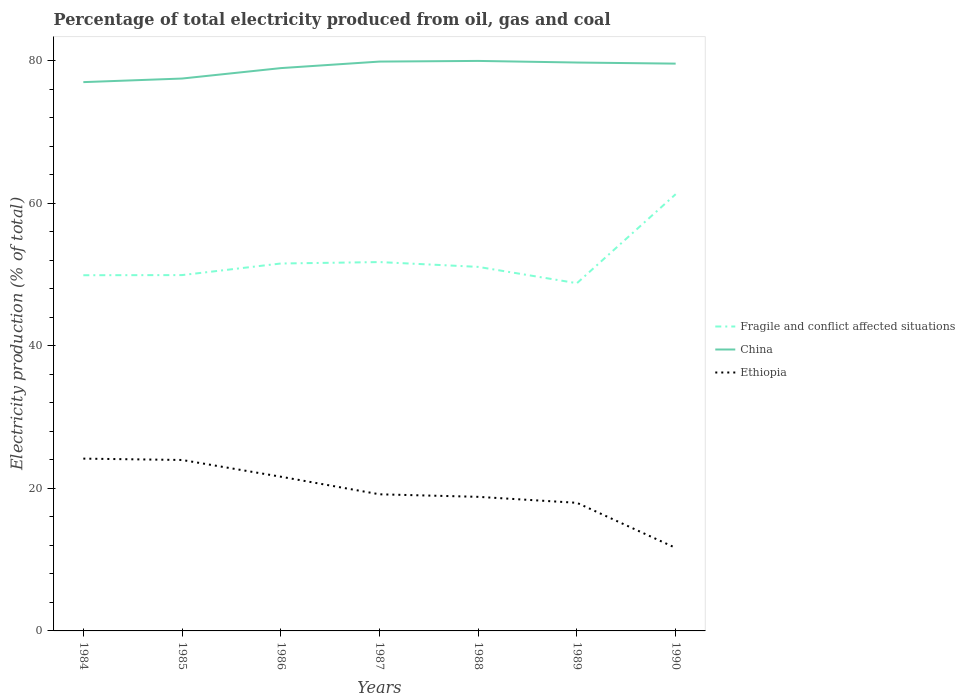Is the number of lines equal to the number of legend labels?
Your response must be concise. Yes. Across all years, what is the maximum electricity production in in Fragile and conflict affected situations?
Your answer should be compact. 48.79. What is the total electricity production in in China in the graph?
Give a very brief answer. 0.22. What is the difference between the highest and the second highest electricity production in in China?
Your answer should be compact. 2.97. What is the difference between the highest and the lowest electricity production in in Ethiopia?
Give a very brief answer. 3. Is the electricity production in in Fragile and conflict affected situations strictly greater than the electricity production in in Ethiopia over the years?
Your answer should be compact. No. How many lines are there?
Keep it short and to the point. 3. How many years are there in the graph?
Ensure brevity in your answer.  7. Does the graph contain any zero values?
Ensure brevity in your answer.  No. How many legend labels are there?
Keep it short and to the point. 3. How are the legend labels stacked?
Provide a short and direct response. Vertical. What is the title of the graph?
Offer a very short reply. Percentage of total electricity produced from oil, gas and coal. What is the label or title of the X-axis?
Offer a terse response. Years. What is the label or title of the Y-axis?
Your answer should be very brief. Electricity production (% of total). What is the Electricity production (% of total) in Fragile and conflict affected situations in 1984?
Keep it short and to the point. 49.91. What is the Electricity production (% of total) in China in 1984?
Provide a succinct answer. 77.01. What is the Electricity production (% of total) of Ethiopia in 1984?
Your answer should be compact. 24.18. What is the Electricity production (% of total) of Fragile and conflict affected situations in 1985?
Your answer should be compact. 49.93. What is the Electricity production (% of total) of China in 1985?
Provide a short and direct response. 77.51. What is the Electricity production (% of total) in Ethiopia in 1985?
Give a very brief answer. 23.99. What is the Electricity production (% of total) of Fragile and conflict affected situations in 1986?
Offer a terse response. 51.55. What is the Electricity production (% of total) in China in 1986?
Offer a very short reply. 78.97. What is the Electricity production (% of total) of Ethiopia in 1986?
Your answer should be compact. 21.64. What is the Electricity production (% of total) of Fragile and conflict affected situations in 1987?
Provide a short and direct response. 51.76. What is the Electricity production (% of total) in China in 1987?
Your response must be concise. 79.89. What is the Electricity production (% of total) of Ethiopia in 1987?
Your answer should be compact. 19.17. What is the Electricity production (% of total) of Fragile and conflict affected situations in 1988?
Keep it short and to the point. 51.08. What is the Electricity production (% of total) in China in 1988?
Give a very brief answer. 79.98. What is the Electricity production (% of total) of Ethiopia in 1988?
Make the answer very short. 18.81. What is the Electricity production (% of total) in Fragile and conflict affected situations in 1989?
Your answer should be very brief. 48.79. What is the Electricity production (% of total) of China in 1989?
Ensure brevity in your answer.  79.76. What is the Electricity production (% of total) of Ethiopia in 1989?
Provide a succinct answer. 17.97. What is the Electricity production (% of total) in Fragile and conflict affected situations in 1990?
Your answer should be very brief. 61.28. What is the Electricity production (% of total) of China in 1990?
Your answer should be very brief. 79.6. What is the Electricity production (% of total) of Ethiopia in 1990?
Make the answer very short. 11.65. Across all years, what is the maximum Electricity production (% of total) in Fragile and conflict affected situations?
Provide a succinct answer. 61.28. Across all years, what is the maximum Electricity production (% of total) in China?
Provide a succinct answer. 79.98. Across all years, what is the maximum Electricity production (% of total) of Ethiopia?
Your response must be concise. 24.18. Across all years, what is the minimum Electricity production (% of total) in Fragile and conflict affected situations?
Keep it short and to the point. 48.79. Across all years, what is the minimum Electricity production (% of total) of China?
Provide a short and direct response. 77.01. Across all years, what is the minimum Electricity production (% of total) of Ethiopia?
Offer a very short reply. 11.65. What is the total Electricity production (% of total) in Fragile and conflict affected situations in the graph?
Offer a terse response. 364.3. What is the total Electricity production (% of total) in China in the graph?
Keep it short and to the point. 552.71. What is the total Electricity production (% of total) of Ethiopia in the graph?
Your answer should be compact. 137.41. What is the difference between the Electricity production (% of total) of Fragile and conflict affected situations in 1984 and that in 1985?
Your answer should be very brief. -0.02. What is the difference between the Electricity production (% of total) of China in 1984 and that in 1985?
Keep it short and to the point. -0.5. What is the difference between the Electricity production (% of total) of Ethiopia in 1984 and that in 1985?
Provide a short and direct response. 0.19. What is the difference between the Electricity production (% of total) of Fragile and conflict affected situations in 1984 and that in 1986?
Your answer should be compact. -1.64. What is the difference between the Electricity production (% of total) of China in 1984 and that in 1986?
Make the answer very short. -1.97. What is the difference between the Electricity production (% of total) of Ethiopia in 1984 and that in 1986?
Provide a succinct answer. 2.54. What is the difference between the Electricity production (% of total) of Fragile and conflict affected situations in 1984 and that in 1987?
Ensure brevity in your answer.  -1.85. What is the difference between the Electricity production (% of total) of China in 1984 and that in 1987?
Your response must be concise. -2.88. What is the difference between the Electricity production (% of total) in Ethiopia in 1984 and that in 1987?
Offer a terse response. 5.01. What is the difference between the Electricity production (% of total) of Fragile and conflict affected situations in 1984 and that in 1988?
Your answer should be compact. -1.17. What is the difference between the Electricity production (% of total) of China in 1984 and that in 1988?
Your response must be concise. -2.98. What is the difference between the Electricity production (% of total) of Ethiopia in 1984 and that in 1988?
Offer a terse response. 5.36. What is the difference between the Electricity production (% of total) of Fragile and conflict affected situations in 1984 and that in 1989?
Provide a succinct answer. 1.12. What is the difference between the Electricity production (% of total) in China in 1984 and that in 1989?
Keep it short and to the point. -2.75. What is the difference between the Electricity production (% of total) of Ethiopia in 1984 and that in 1989?
Make the answer very short. 6.2. What is the difference between the Electricity production (% of total) of Fragile and conflict affected situations in 1984 and that in 1990?
Ensure brevity in your answer.  -11.37. What is the difference between the Electricity production (% of total) in China in 1984 and that in 1990?
Make the answer very short. -2.6. What is the difference between the Electricity production (% of total) in Ethiopia in 1984 and that in 1990?
Your response must be concise. 12.53. What is the difference between the Electricity production (% of total) in Fragile and conflict affected situations in 1985 and that in 1986?
Keep it short and to the point. -1.63. What is the difference between the Electricity production (% of total) in China in 1985 and that in 1986?
Ensure brevity in your answer.  -1.46. What is the difference between the Electricity production (% of total) of Ethiopia in 1985 and that in 1986?
Offer a terse response. 2.35. What is the difference between the Electricity production (% of total) of Fragile and conflict affected situations in 1985 and that in 1987?
Offer a very short reply. -1.83. What is the difference between the Electricity production (% of total) in China in 1985 and that in 1987?
Your response must be concise. -2.38. What is the difference between the Electricity production (% of total) of Ethiopia in 1985 and that in 1987?
Ensure brevity in your answer.  4.82. What is the difference between the Electricity production (% of total) in Fragile and conflict affected situations in 1985 and that in 1988?
Make the answer very short. -1.15. What is the difference between the Electricity production (% of total) in China in 1985 and that in 1988?
Your response must be concise. -2.47. What is the difference between the Electricity production (% of total) in Ethiopia in 1985 and that in 1988?
Your answer should be very brief. 5.17. What is the difference between the Electricity production (% of total) of Fragile and conflict affected situations in 1985 and that in 1989?
Your response must be concise. 1.14. What is the difference between the Electricity production (% of total) of China in 1985 and that in 1989?
Your response must be concise. -2.25. What is the difference between the Electricity production (% of total) in Ethiopia in 1985 and that in 1989?
Your response must be concise. 6.01. What is the difference between the Electricity production (% of total) of Fragile and conflict affected situations in 1985 and that in 1990?
Keep it short and to the point. -11.35. What is the difference between the Electricity production (% of total) of China in 1985 and that in 1990?
Offer a very short reply. -2.09. What is the difference between the Electricity production (% of total) in Ethiopia in 1985 and that in 1990?
Offer a terse response. 12.34. What is the difference between the Electricity production (% of total) in Fragile and conflict affected situations in 1986 and that in 1987?
Provide a succinct answer. -0.2. What is the difference between the Electricity production (% of total) in China in 1986 and that in 1987?
Provide a short and direct response. -0.92. What is the difference between the Electricity production (% of total) in Ethiopia in 1986 and that in 1987?
Ensure brevity in your answer.  2.47. What is the difference between the Electricity production (% of total) of Fragile and conflict affected situations in 1986 and that in 1988?
Your response must be concise. 0.47. What is the difference between the Electricity production (% of total) of China in 1986 and that in 1988?
Your answer should be compact. -1.01. What is the difference between the Electricity production (% of total) in Ethiopia in 1986 and that in 1988?
Provide a succinct answer. 2.83. What is the difference between the Electricity production (% of total) in Fragile and conflict affected situations in 1986 and that in 1989?
Provide a short and direct response. 2.76. What is the difference between the Electricity production (% of total) in China in 1986 and that in 1989?
Give a very brief answer. -0.78. What is the difference between the Electricity production (% of total) of Ethiopia in 1986 and that in 1989?
Give a very brief answer. 3.66. What is the difference between the Electricity production (% of total) in Fragile and conflict affected situations in 1986 and that in 1990?
Make the answer very short. -9.72. What is the difference between the Electricity production (% of total) in China in 1986 and that in 1990?
Provide a short and direct response. -0.63. What is the difference between the Electricity production (% of total) in Ethiopia in 1986 and that in 1990?
Keep it short and to the point. 9.99. What is the difference between the Electricity production (% of total) in Fragile and conflict affected situations in 1987 and that in 1988?
Make the answer very short. 0.68. What is the difference between the Electricity production (% of total) in China in 1987 and that in 1988?
Your answer should be very brief. -0.09. What is the difference between the Electricity production (% of total) of Ethiopia in 1987 and that in 1988?
Make the answer very short. 0.36. What is the difference between the Electricity production (% of total) of Fragile and conflict affected situations in 1987 and that in 1989?
Ensure brevity in your answer.  2.96. What is the difference between the Electricity production (% of total) of China in 1987 and that in 1989?
Make the answer very short. 0.13. What is the difference between the Electricity production (% of total) in Ethiopia in 1987 and that in 1989?
Provide a succinct answer. 1.2. What is the difference between the Electricity production (% of total) in Fragile and conflict affected situations in 1987 and that in 1990?
Make the answer very short. -9.52. What is the difference between the Electricity production (% of total) in China in 1987 and that in 1990?
Your answer should be very brief. 0.29. What is the difference between the Electricity production (% of total) in Ethiopia in 1987 and that in 1990?
Your answer should be very brief. 7.52. What is the difference between the Electricity production (% of total) of Fragile and conflict affected situations in 1988 and that in 1989?
Keep it short and to the point. 2.29. What is the difference between the Electricity production (% of total) of China in 1988 and that in 1989?
Make the answer very short. 0.22. What is the difference between the Electricity production (% of total) in Ethiopia in 1988 and that in 1989?
Provide a succinct answer. 0.84. What is the difference between the Electricity production (% of total) in Fragile and conflict affected situations in 1988 and that in 1990?
Ensure brevity in your answer.  -10.2. What is the difference between the Electricity production (% of total) of China in 1988 and that in 1990?
Keep it short and to the point. 0.38. What is the difference between the Electricity production (% of total) of Ethiopia in 1988 and that in 1990?
Your response must be concise. 7.17. What is the difference between the Electricity production (% of total) of Fragile and conflict affected situations in 1989 and that in 1990?
Provide a succinct answer. -12.49. What is the difference between the Electricity production (% of total) of China in 1989 and that in 1990?
Keep it short and to the point. 0.16. What is the difference between the Electricity production (% of total) of Ethiopia in 1989 and that in 1990?
Give a very brief answer. 6.33. What is the difference between the Electricity production (% of total) in Fragile and conflict affected situations in 1984 and the Electricity production (% of total) in China in 1985?
Keep it short and to the point. -27.6. What is the difference between the Electricity production (% of total) in Fragile and conflict affected situations in 1984 and the Electricity production (% of total) in Ethiopia in 1985?
Provide a short and direct response. 25.92. What is the difference between the Electricity production (% of total) in China in 1984 and the Electricity production (% of total) in Ethiopia in 1985?
Your response must be concise. 53.02. What is the difference between the Electricity production (% of total) in Fragile and conflict affected situations in 1984 and the Electricity production (% of total) in China in 1986?
Keep it short and to the point. -29.06. What is the difference between the Electricity production (% of total) of Fragile and conflict affected situations in 1984 and the Electricity production (% of total) of Ethiopia in 1986?
Your response must be concise. 28.27. What is the difference between the Electricity production (% of total) in China in 1984 and the Electricity production (% of total) in Ethiopia in 1986?
Keep it short and to the point. 55.37. What is the difference between the Electricity production (% of total) in Fragile and conflict affected situations in 1984 and the Electricity production (% of total) in China in 1987?
Ensure brevity in your answer.  -29.98. What is the difference between the Electricity production (% of total) of Fragile and conflict affected situations in 1984 and the Electricity production (% of total) of Ethiopia in 1987?
Your response must be concise. 30.74. What is the difference between the Electricity production (% of total) of China in 1984 and the Electricity production (% of total) of Ethiopia in 1987?
Your answer should be very brief. 57.83. What is the difference between the Electricity production (% of total) of Fragile and conflict affected situations in 1984 and the Electricity production (% of total) of China in 1988?
Your answer should be very brief. -30.07. What is the difference between the Electricity production (% of total) of Fragile and conflict affected situations in 1984 and the Electricity production (% of total) of Ethiopia in 1988?
Your answer should be compact. 31.1. What is the difference between the Electricity production (% of total) in China in 1984 and the Electricity production (% of total) in Ethiopia in 1988?
Offer a terse response. 58.19. What is the difference between the Electricity production (% of total) of Fragile and conflict affected situations in 1984 and the Electricity production (% of total) of China in 1989?
Offer a terse response. -29.85. What is the difference between the Electricity production (% of total) in Fragile and conflict affected situations in 1984 and the Electricity production (% of total) in Ethiopia in 1989?
Offer a very short reply. 31.93. What is the difference between the Electricity production (% of total) of China in 1984 and the Electricity production (% of total) of Ethiopia in 1989?
Ensure brevity in your answer.  59.03. What is the difference between the Electricity production (% of total) of Fragile and conflict affected situations in 1984 and the Electricity production (% of total) of China in 1990?
Your answer should be compact. -29.69. What is the difference between the Electricity production (% of total) of Fragile and conflict affected situations in 1984 and the Electricity production (% of total) of Ethiopia in 1990?
Ensure brevity in your answer.  38.26. What is the difference between the Electricity production (% of total) in China in 1984 and the Electricity production (% of total) in Ethiopia in 1990?
Offer a terse response. 65.36. What is the difference between the Electricity production (% of total) of Fragile and conflict affected situations in 1985 and the Electricity production (% of total) of China in 1986?
Your answer should be compact. -29.04. What is the difference between the Electricity production (% of total) in Fragile and conflict affected situations in 1985 and the Electricity production (% of total) in Ethiopia in 1986?
Provide a short and direct response. 28.29. What is the difference between the Electricity production (% of total) in China in 1985 and the Electricity production (% of total) in Ethiopia in 1986?
Your answer should be compact. 55.87. What is the difference between the Electricity production (% of total) of Fragile and conflict affected situations in 1985 and the Electricity production (% of total) of China in 1987?
Offer a very short reply. -29.96. What is the difference between the Electricity production (% of total) of Fragile and conflict affected situations in 1985 and the Electricity production (% of total) of Ethiopia in 1987?
Ensure brevity in your answer.  30.76. What is the difference between the Electricity production (% of total) in China in 1985 and the Electricity production (% of total) in Ethiopia in 1987?
Ensure brevity in your answer.  58.34. What is the difference between the Electricity production (% of total) in Fragile and conflict affected situations in 1985 and the Electricity production (% of total) in China in 1988?
Offer a terse response. -30.05. What is the difference between the Electricity production (% of total) of Fragile and conflict affected situations in 1985 and the Electricity production (% of total) of Ethiopia in 1988?
Your answer should be compact. 31.11. What is the difference between the Electricity production (% of total) of China in 1985 and the Electricity production (% of total) of Ethiopia in 1988?
Make the answer very short. 58.69. What is the difference between the Electricity production (% of total) in Fragile and conflict affected situations in 1985 and the Electricity production (% of total) in China in 1989?
Your response must be concise. -29.83. What is the difference between the Electricity production (% of total) in Fragile and conflict affected situations in 1985 and the Electricity production (% of total) in Ethiopia in 1989?
Your response must be concise. 31.95. What is the difference between the Electricity production (% of total) in China in 1985 and the Electricity production (% of total) in Ethiopia in 1989?
Your answer should be very brief. 59.53. What is the difference between the Electricity production (% of total) in Fragile and conflict affected situations in 1985 and the Electricity production (% of total) in China in 1990?
Your answer should be compact. -29.67. What is the difference between the Electricity production (% of total) in Fragile and conflict affected situations in 1985 and the Electricity production (% of total) in Ethiopia in 1990?
Your answer should be very brief. 38.28. What is the difference between the Electricity production (% of total) of China in 1985 and the Electricity production (% of total) of Ethiopia in 1990?
Offer a terse response. 65.86. What is the difference between the Electricity production (% of total) in Fragile and conflict affected situations in 1986 and the Electricity production (% of total) in China in 1987?
Provide a short and direct response. -28.33. What is the difference between the Electricity production (% of total) in Fragile and conflict affected situations in 1986 and the Electricity production (% of total) in Ethiopia in 1987?
Provide a short and direct response. 32.38. What is the difference between the Electricity production (% of total) of China in 1986 and the Electricity production (% of total) of Ethiopia in 1987?
Offer a terse response. 59.8. What is the difference between the Electricity production (% of total) of Fragile and conflict affected situations in 1986 and the Electricity production (% of total) of China in 1988?
Make the answer very short. -28.43. What is the difference between the Electricity production (% of total) in Fragile and conflict affected situations in 1986 and the Electricity production (% of total) in Ethiopia in 1988?
Your answer should be compact. 32.74. What is the difference between the Electricity production (% of total) of China in 1986 and the Electricity production (% of total) of Ethiopia in 1988?
Your response must be concise. 60.16. What is the difference between the Electricity production (% of total) of Fragile and conflict affected situations in 1986 and the Electricity production (% of total) of China in 1989?
Your answer should be compact. -28.2. What is the difference between the Electricity production (% of total) in Fragile and conflict affected situations in 1986 and the Electricity production (% of total) in Ethiopia in 1989?
Offer a terse response. 33.58. What is the difference between the Electricity production (% of total) of China in 1986 and the Electricity production (% of total) of Ethiopia in 1989?
Keep it short and to the point. 61. What is the difference between the Electricity production (% of total) of Fragile and conflict affected situations in 1986 and the Electricity production (% of total) of China in 1990?
Make the answer very short. -28.05. What is the difference between the Electricity production (% of total) in Fragile and conflict affected situations in 1986 and the Electricity production (% of total) in Ethiopia in 1990?
Keep it short and to the point. 39.91. What is the difference between the Electricity production (% of total) in China in 1986 and the Electricity production (% of total) in Ethiopia in 1990?
Provide a short and direct response. 67.32. What is the difference between the Electricity production (% of total) of Fragile and conflict affected situations in 1987 and the Electricity production (% of total) of China in 1988?
Provide a succinct answer. -28.22. What is the difference between the Electricity production (% of total) of Fragile and conflict affected situations in 1987 and the Electricity production (% of total) of Ethiopia in 1988?
Give a very brief answer. 32.94. What is the difference between the Electricity production (% of total) of China in 1987 and the Electricity production (% of total) of Ethiopia in 1988?
Provide a short and direct response. 61.07. What is the difference between the Electricity production (% of total) of Fragile and conflict affected situations in 1987 and the Electricity production (% of total) of China in 1989?
Offer a terse response. -28. What is the difference between the Electricity production (% of total) of Fragile and conflict affected situations in 1987 and the Electricity production (% of total) of Ethiopia in 1989?
Your answer should be compact. 33.78. What is the difference between the Electricity production (% of total) of China in 1987 and the Electricity production (% of total) of Ethiopia in 1989?
Your answer should be compact. 61.91. What is the difference between the Electricity production (% of total) of Fragile and conflict affected situations in 1987 and the Electricity production (% of total) of China in 1990?
Ensure brevity in your answer.  -27.84. What is the difference between the Electricity production (% of total) in Fragile and conflict affected situations in 1987 and the Electricity production (% of total) in Ethiopia in 1990?
Offer a very short reply. 40.11. What is the difference between the Electricity production (% of total) in China in 1987 and the Electricity production (% of total) in Ethiopia in 1990?
Keep it short and to the point. 68.24. What is the difference between the Electricity production (% of total) in Fragile and conflict affected situations in 1988 and the Electricity production (% of total) in China in 1989?
Make the answer very short. -28.67. What is the difference between the Electricity production (% of total) in Fragile and conflict affected situations in 1988 and the Electricity production (% of total) in Ethiopia in 1989?
Ensure brevity in your answer.  33.11. What is the difference between the Electricity production (% of total) in China in 1988 and the Electricity production (% of total) in Ethiopia in 1989?
Keep it short and to the point. 62.01. What is the difference between the Electricity production (% of total) in Fragile and conflict affected situations in 1988 and the Electricity production (% of total) in China in 1990?
Provide a short and direct response. -28.52. What is the difference between the Electricity production (% of total) of Fragile and conflict affected situations in 1988 and the Electricity production (% of total) of Ethiopia in 1990?
Your answer should be compact. 39.43. What is the difference between the Electricity production (% of total) of China in 1988 and the Electricity production (% of total) of Ethiopia in 1990?
Give a very brief answer. 68.33. What is the difference between the Electricity production (% of total) in Fragile and conflict affected situations in 1989 and the Electricity production (% of total) in China in 1990?
Give a very brief answer. -30.81. What is the difference between the Electricity production (% of total) in Fragile and conflict affected situations in 1989 and the Electricity production (% of total) in Ethiopia in 1990?
Give a very brief answer. 37.14. What is the difference between the Electricity production (% of total) of China in 1989 and the Electricity production (% of total) of Ethiopia in 1990?
Offer a terse response. 68.11. What is the average Electricity production (% of total) of Fragile and conflict affected situations per year?
Your response must be concise. 52.04. What is the average Electricity production (% of total) of China per year?
Your answer should be compact. 78.96. What is the average Electricity production (% of total) in Ethiopia per year?
Ensure brevity in your answer.  19.63. In the year 1984, what is the difference between the Electricity production (% of total) of Fragile and conflict affected situations and Electricity production (% of total) of China?
Ensure brevity in your answer.  -27.1. In the year 1984, what is the difference between the Electricity production (% of total) in Fragile and conflict affected situations and Electricity production (% of total) in Ethiopia?
Your answer should be compact. 25.73. In the year 1984, what is the difference between the Electricity production (% of total) of China and Electricity production (% of total) of Ethiopia?
Make the answer very short. 52.83. In the year 1985, what is the difference between the Electricity production (% of total) in Fragile and conflict affected situations and Electricity production (% of total) in China?
Offer a terse response. -27.58. In the year 1985, what is the difference between the Electricity production (% of total) of Fragile and conflict affected situations and Electricity production (% of total) of Ethiopia?
Ensure brevity in your answer.  25.94. In the year 1985, what is the difference between the Electricity production (% of total) in China and Electricity production (% of total) in Ethiopia?
Make the answer very short. 53.52. In the year 1986, what is the difference between the Electricity production (% of total) in Fragile and conflict affected situations and Electricity production (% of total) in China?
Offer a terse response. -27.42. In the year 1986, what is the difference between the Electricity production (% of total) in Fragile and conflict affected situations and Electricity production (% of total) in Ethiopia?
Keep it short and to the point. 29.91. In the year 1986, what is the difference between the Electricity production (% of total) in China and Electricity production (% of total) in Ethiopia?
Give a very brief answer. 57.33. In the year 1987, what is the difference between the Electricity production (% of total) of Fragile and conflict affected situations and Electricity production (% of total) of China?
Keep it short and to the point. -28.13. In the year 1987, what is the difference between the Electricity production (% of total) of Fragile and conflict affected situations and Electricity production (% of total) of Ethiopia?
Ensure brevity in your answer.  32.59. In the year 1987, what is the difference between the Electricity production (% of total) in China and Electricity production (% of total) in Ethiopia?
Keep it short and to the point. 60.72. In the year 1988, what is the difference between the Electricity production (% of total) in Fragile and conflict affected situations and Electricity production (% of total) in China?
Offer a terse response. -28.9. In the year 1988, what is the difference between the Electricity production (% of total) in Fragile and conflict affected situations and Electricity production (% of total) in Ethiopia?
Provide a short and direct response. 32.27. In the year 1988, what is the difference between the Electricity production (% of total) of China and Electricity production (% of total) of Ethiopia?
Your response must be concise. 61.17. In the year 1989, what is the difference between the Electricity production (% of total) in Fragile and conflict affected situations and Electricity production (% of total) in China?
Ensure brevity in your answer.  -30.96. In the year 1989, what is the difference between the Electricity production (% of total) in Fragile and conflict affected situations and Electricity production (% of total) in Ethiopia?
Make the answer very short. 30.82. In the year 1989, what is the difference between the Electricity production (% of total) in China and Electricity production (% of total) in Ethiopia?
Ensure brevity in your answer.  61.78. In the year 1990, what is the difference between the Electricity production (% of total) of Fragile and conflict affected situations and Electricity production (% of total) of China?
Provide a succinct answer. -18.32. In the year 1990, what is the difference between the Electricity production (% of total) in Fragile and conflict affected situations and Electricity production (% of total) in Ethiopia?
Provide a short and direct response. 49.63. In the year 1990, what is the difference between the Electricity production (% of total) in China and Electricity production (% of total) in Ethiopia?
Your answer should be very brief. 67.95. What is the ratio of the Electricity production (% of total) of Ethiopia in 1984 to that in 1985?
Offer a terse response. 1.01. What is the ratio of the Electricity production (% of total) of Fragile and conflict affected situations in 1984 to that in 1986?
Keep it short and to the point. 0.97. What is the ratio of the Electricity production (% of total) in China in 1984 to that in 1986?
Offer a terse response. 0.98. What is the ratio of the Electricity production (% of total) of Ethiopia in 1984 to that in 1986?
Offer a terse response. 1.12. What is the ratio of the Electricity production (% of total) in China in 1984 to that in 1987?
Provide a short and direct response. 0.96. What is the ratio of the Electricity production (% of total) of Ethiopia in 1984 to that in 1987?
Your response must be concise. 1.26. What is the ratio of the Electricity production (% of total) in Fragile and conflict affected situations in 1984 to that in 1988?
Ensure brevity in your answer.  0.98. What is the ratio of the Electricity production (% of total) of China in 1984 to that in 1988?
Provide a short and direct response. 0.96. What is the ratio of the Electricity production (% of total) in Ethiopia in 1984 to that in 1988?
Offer a very short reply. 1.28. What is the ratio of the Electricity production (% of total) in Fragile and conflict affected situations in 1984 to that in 1989?
Offer a terse response. 1.02. What is the ratio of the Electricity production (% of total) of China in 1984 to that in 1989?
Make the answer very short. 0.97. What is the ratio of the Electricity production (% of total) in Ethiopia in 1984 to that in 1989?
Ensure brevity in your answer.  1.34. What is the ratio of the Electricity production (% of total) of Fragile and conflict affected situations in 1984 to that in 1990?
Your response must be concise. 0.81. What is the ratio of the Electricity production (% of total) in China in 1984 to that in 1990?
Your answer should be very brief. 0.97. What is the ratio of the Electricity production (% of total) in Ethiopia in 1984 to that in 1990?
Ensure brevity in your answer.  2.08. What is the ratio of the Electricity production (% of total) of Fragile and conflict affected situations in 1985 to that in 1986?
Provide a short and direct response. 0.97. What is the ratio of the Electricity production (% of total) in China in 1985 to that in 1986?
Your answer should be compact. 0.98. What is the ratio of the Electricity production (% of total) of Ethiopia in 1985 to that in 1986?
Your answer should be very brief. 1.11. What is the ratio of the Electricity production (% of total) of Fragile and conflict affected situations in 1985 to that in 1987?
Your answer should be very brief. 0.96. What is the ratio of the Electricity production (% of total) of China in 1985 to that in 1987?
Offer a very short reply. 0.97. What is the ratio of the Electricity production (% of total) of Ethiopia in 1985 to that in 1987?
Offer a very short reply. 1.25. What is the ratio of the Electricity production (% of total) of Fragile and conflict affected situations in 1985 to that in 1988?
Ensure brevity in your answer.  0.98. What is the ratio of the Electricity production (% of total) of China in 1985 to that in 1988?
Your response must be concise. 0.97. What is the ratio of the Electricity production (% of total) of Ethiopia in 1985 to that in 1988?
Give a very brief answer. 1.27. What is the ratio of the Electricity production (% of total) of Fragile and conflict affected situations in 1985 to that in 1989?
Give a very brief answer. 1.02. What is the ratio of the Electricity production (% of total) of China in 1985 to that in 1989?
Your answer should be very brief. 0.97. What is the ratio of the Electricity production (% of total) in Ethiopia in 1985 to that in 1989?
Offer a terse response. 1.33. What is the ratio of the Electricity production (% of total) of Fragile and conflict affected situations in 1985 to that in 1990?
Your answer should be compact. 0.81. What is the ratio of the Electricity production (% of total) of China in 1985 to that in 1990?
Your answer should be compact. 0.97. What is the ratio of the Electricity production (% of total) in Ethiopia in 1985 to that in 1990?
Give a very brief answer. 2.06. What is the ratio of the Electricity production (% of total) of Ethiopia in 1986 to that in 1987?
Offer a very short reply. 1.13. What is the ratio of the Electricity production (% of total) of Fragile and conflict affected situations in 1986 to that in 1988?
Your answer should be compact. 1.01. What is the ratio of the Electricity production (% of total) in China in 1986 to that in 1988?
Make the answer very short. 0.99. What is the ratio of the Electricity production (% of total) of Ethiopia in 1986 to that in 1988?
Provide a succinct answer. 1.15. What is the ratio of the Electricity production (% of total) of Fragile and conflict affected situations in 1986 to that in 1989?
Your answer should be compact. 1.06. What is the ratio of the Electricity production (% of total) of China in 1986 to that in 1989?
Ensure brevity in your answer.  0.99. What is the ratio of the Electricity production (% of total) in Ethiopia in 1986 to that in 1989?
Ensure brevity in your answer.  1.2. What is the ratio of the Electricity production (% of total) of Fragile and conflict affected situations in 1986 to that in 1990?
Keep it short and to the point. 0.84. What is the ratio of the Electricity production (% of total) of Ethiopia in 1986 to that in 1990?
Offer a very short reply. 1.86. What is the ratio of the Electricity production (% of total) of Fragile and conflict affected situations in 1987 to that in 1988?
Ensure brevity in your answer.  1.01. What is the ratio of the Electricity production (% of total) of China in 1987 to that in 1988?
Your answer should be compact. 1. What is the ratio of the Electricity production (% of total) in Ethiopia in 1987 to that in 1988?
Your response must be concise. 1.02. What is the ratio of the Electricity production (% of total) in Fragile and conflict affected situations in 1987 to that in 1989?
Offer a terse response. 1.06. What is the ratio of the Electricity production (% of total) of Ethiopia in 1987 to that in 1989?
Give a very brief answer. 1.07. What is the ratio of the Electricity production (% of total) of Fragile and conflict affected situations in 1987 to that in 1990?
Ensure brevity in your answer.  0.84. What is the ratio of the Electricity production (% of total) in China in 1987 to that in 1990?
Ensure brevity in your answer.  1. What is the ratio of the Electricity production (% of total) of Ethiopia in 1987 to that in 1990?
Offer a very short reply. 1.65. What is the ratio of the Electricity production (% of total) in Fragile and conflict affected situations in 1988 to that in 1989?
Give a very brief answer. 1.05. What is the ratio of the Electricity production (% of total) in China in 1988 to that in 1989?
Offer a very short reply. 1. What is the ratio of the Electricity production (% of total) in Ethiopia in 1988 to that in 1989?
Provide a short and direct response. 1.05. What is the ratio of the Electricity production (% of total) of Fragile and conflict affected situations in 1988 to that in 1990?
Provide a short and direct response. 0.83. What is the ratio of the Electricity production (% of total) in China in 1988 to that in 1990?
Give a very brief answer. 1. What is the ratio of the Electricity production (% of total) of Ethiopia in 1988 to that in 1990?
Your answer should be compact. 1.62. What is the ratio of the Electricity production (% of total) in Fragile and conflict affected situations in 1989 to that in 1990?
Your answer should be compact. 0.8. What is the ratio of the Electricity production (% of total) of Ethiopia in 1989 to that in 1990?
Offer a terse response. 1.54. What is the difference between the highest and the second highest Electricity production (% of total) in Fragile and conflict affected situations?
Provide a short and direct response. 9.52. What is the difference between the highest and the second highest Electricity production (% of total) in China?
Provide a succinct answer. 0.09. What is the difference between the highest and the second highest Electricity production (% of total) of Ethiopia?
Ensure brevity in your answer.  0.19. What is the difference between the highest and the lowest Electricity production (% of total) of Fragile and conflict affected situations?
Your answer should be very brief. 12.49. What is the difference between the highest and the lowest Electricity production (% of total) in China?
Your answer should be compact. 2.98. What is the difference between the highest and the lowest Electricity production (% of total) of Ethiopia?
Give a very brief answer. 12.53. 